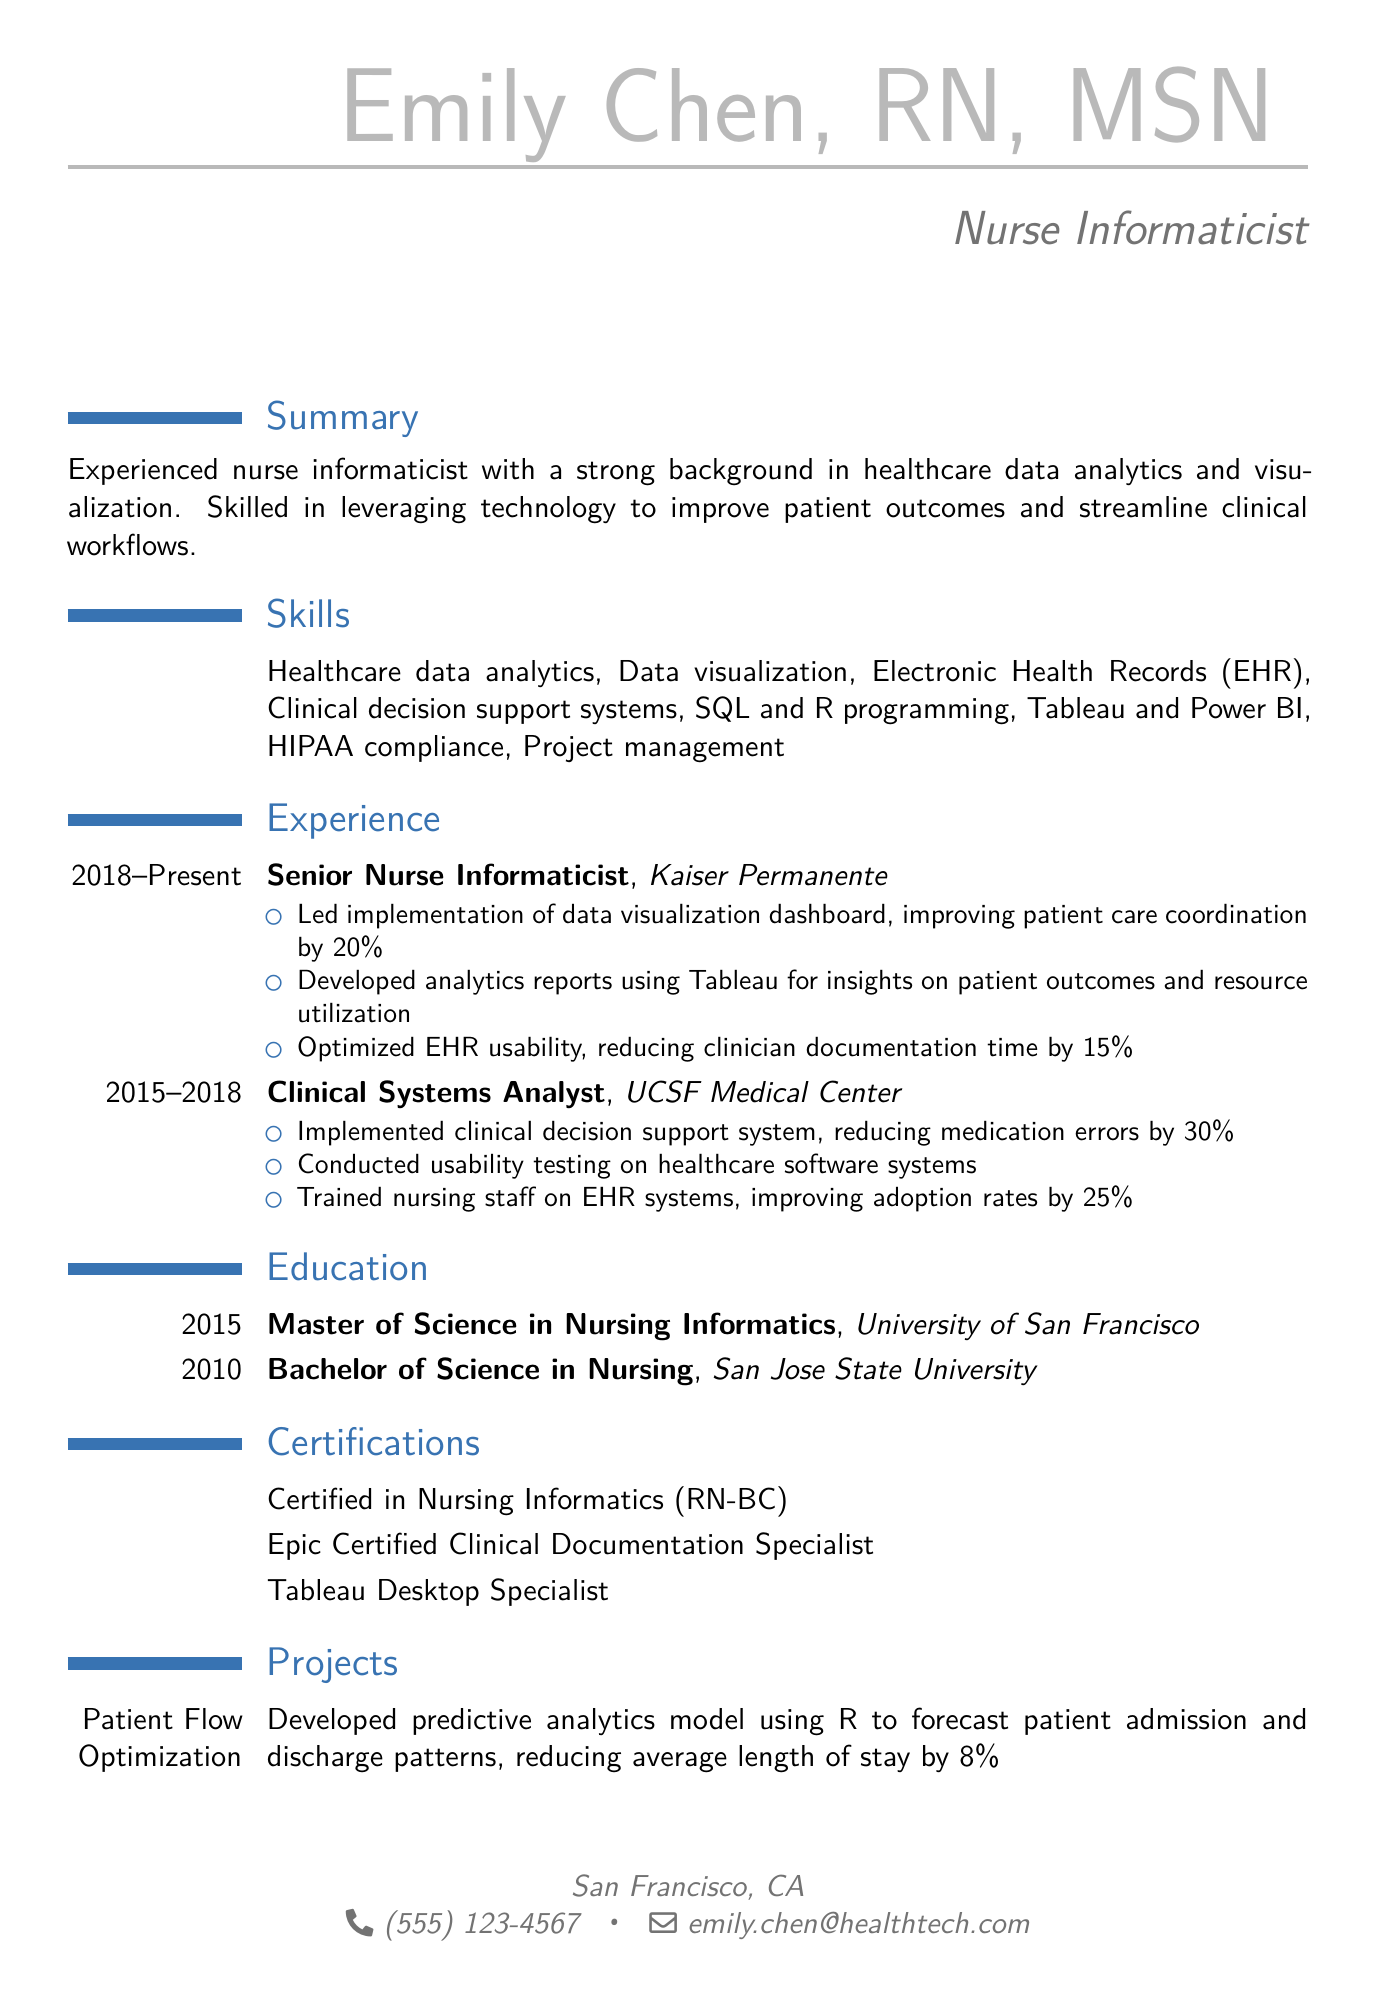what is the name of the individual? The document starts with the individual's name, which is listed prominently at the top.
Answer: Emily Chen, RN, MSN what is the current job title? The job title follows the name in the document, indicating the individual's professional role.
Answer: Nurse Informaticist which company does the individual currently work for? The most recent job position provides the name of the current employer at the top of the experience section.
Answer: Kaiser Permanente how many years of experience does the individual have at Kaiser Permanente? The duration of employment is specified right next to the job title in the experience section.
Answer: 5 years what percentage improvement was achieved in patient care coordination? The achievements listed in the experience section specify the result of the implemented dashboard in numerical terms.
Answer: 20% which skill is related to compliance in healthcare? The skills section includes a specific term that refers to regulations and standards in the healthcare field.
Answer: HIPAA compliance what was the result of the EHR interface redesign? The project description provides a quantitative result related to user satisfaction from the EHR usability enhancement project.
Answer: 95% satisfaction rate which programming languages is the individual proficient in? The skills section mentions specific programming languages used by the individual for analytics and data management.
Answer: SQL and R programming how many years ago did the individual complete their Bachelor's degree? The education section lists the year the degree was completed, and calculation is needed to determine how many years ago that was from the current date.
Answer: 13 years ago what certification demonstrates expertise in nursing informatics? The certifications section includes a specific certification that highlights the individual's qualifications in their field.
Answer: Certified in Nursing Informatics (RN-BC) 